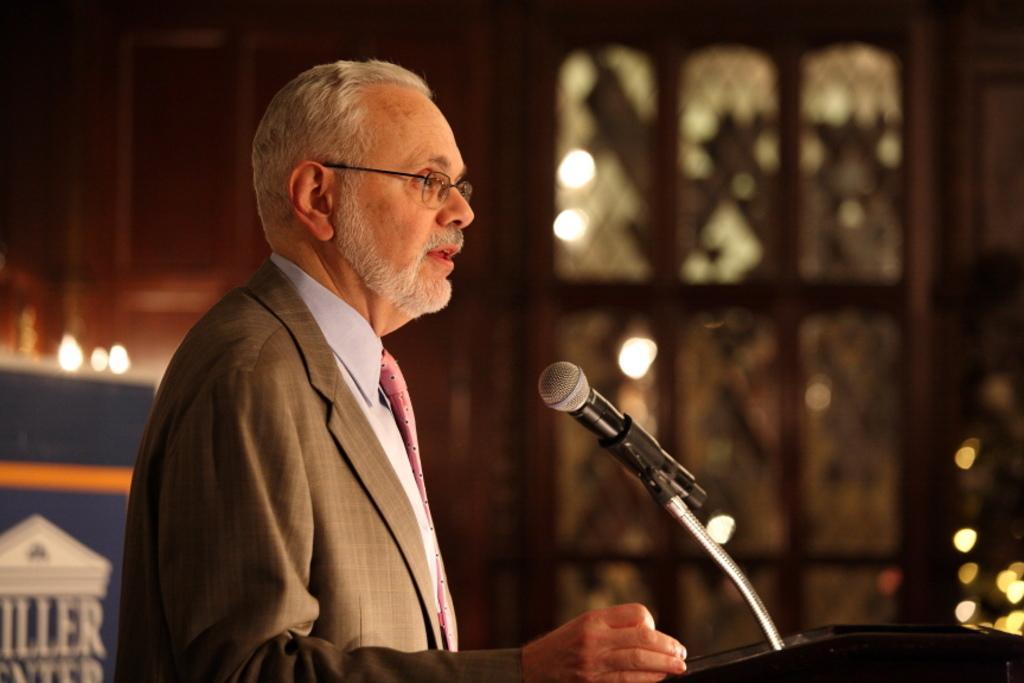Please provide a concise description of this image. In this image we can see a person standing in front of the podium, on the podium, we can see a mic, behind we can see a board with some image and also we can see the windows. 